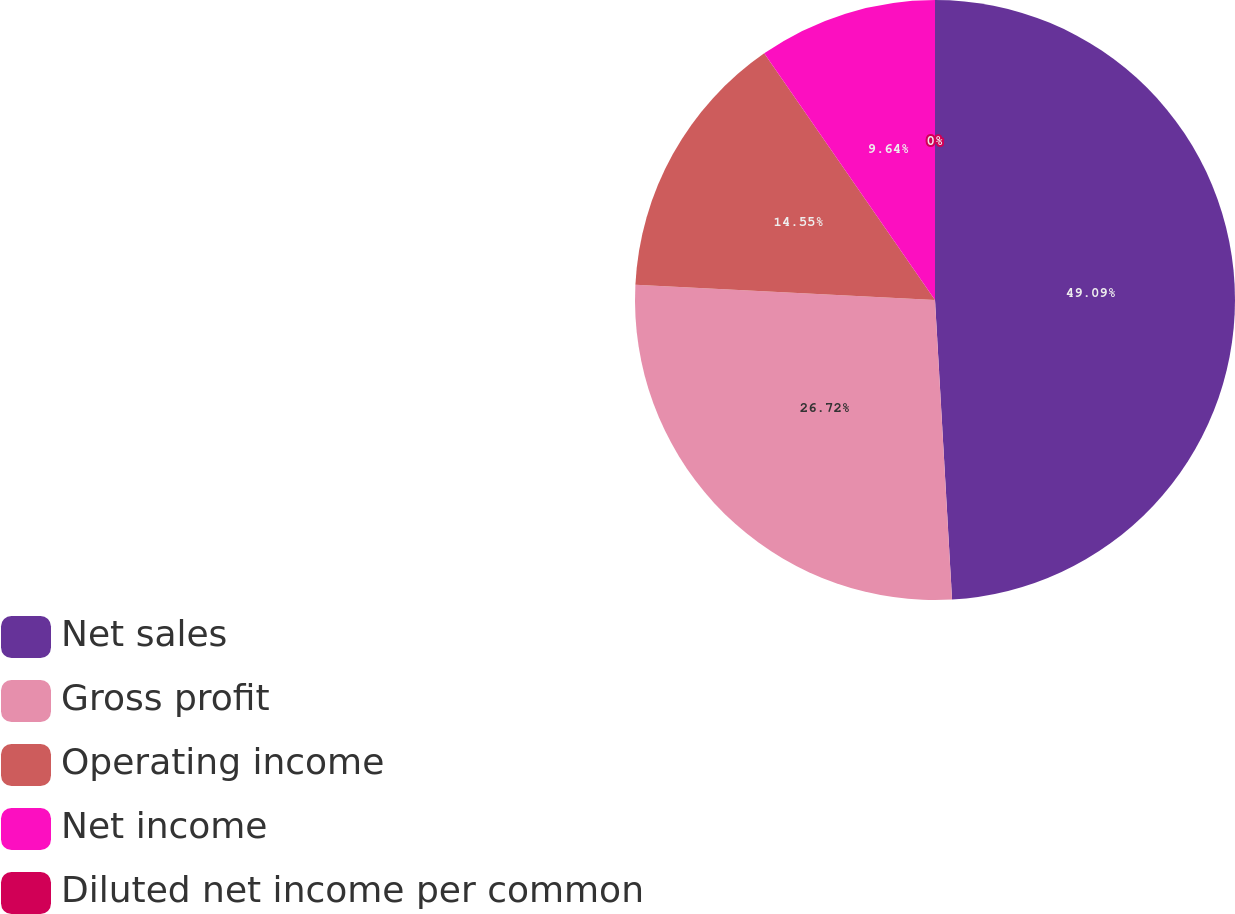<chart> <loc_0><loc_0><loc_500><loc_500><pie_chart><fcel>Net sales<fcel>Gross profit<fcel>Operating income<fcel>Net income<fcel>Diluted net income per common<nl><fcel>49.1%<fcel>26.72%<fcel>14.55%<fcel>9.64%<fcel>0.0%<nl></chart> 